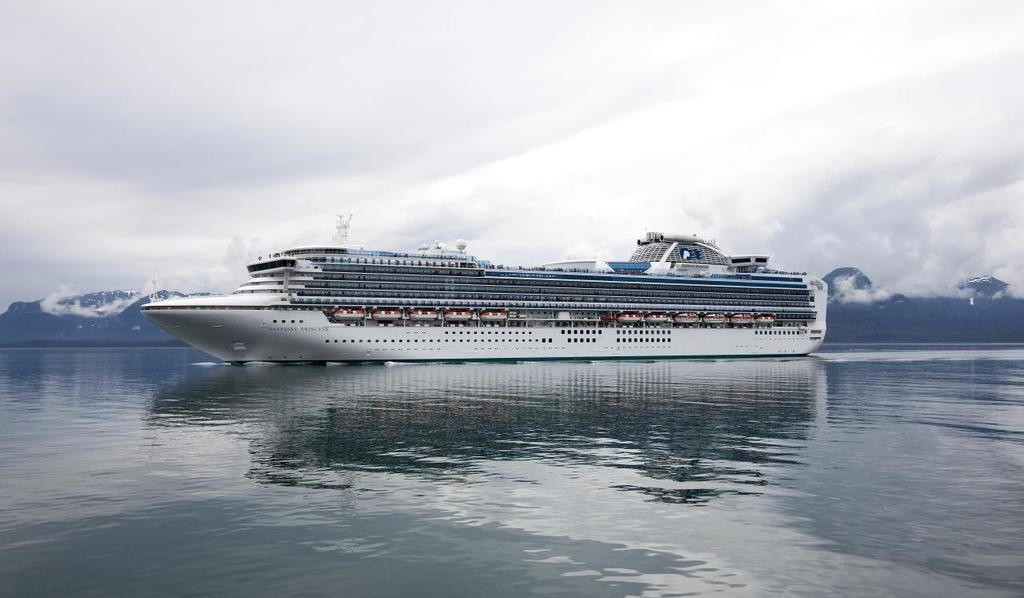What is the main subject of the image? The main subject of the image is a ship. Where is the ship located? The ship is on water. What can be seen in the background of the image? There are mountains and the sky visible in the background of the image. What type of leather is being used to make the caption on the ship? There is no caption present on the ship in the image, and therefore no leather is involved. 